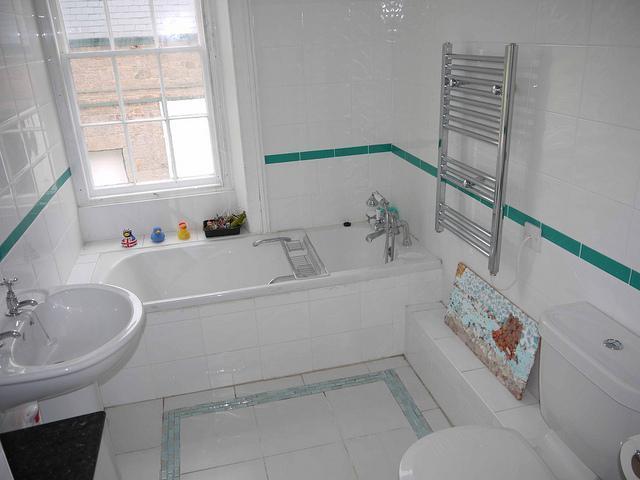How many people are holding umbrellas?
Give a very brief answer. 0. 